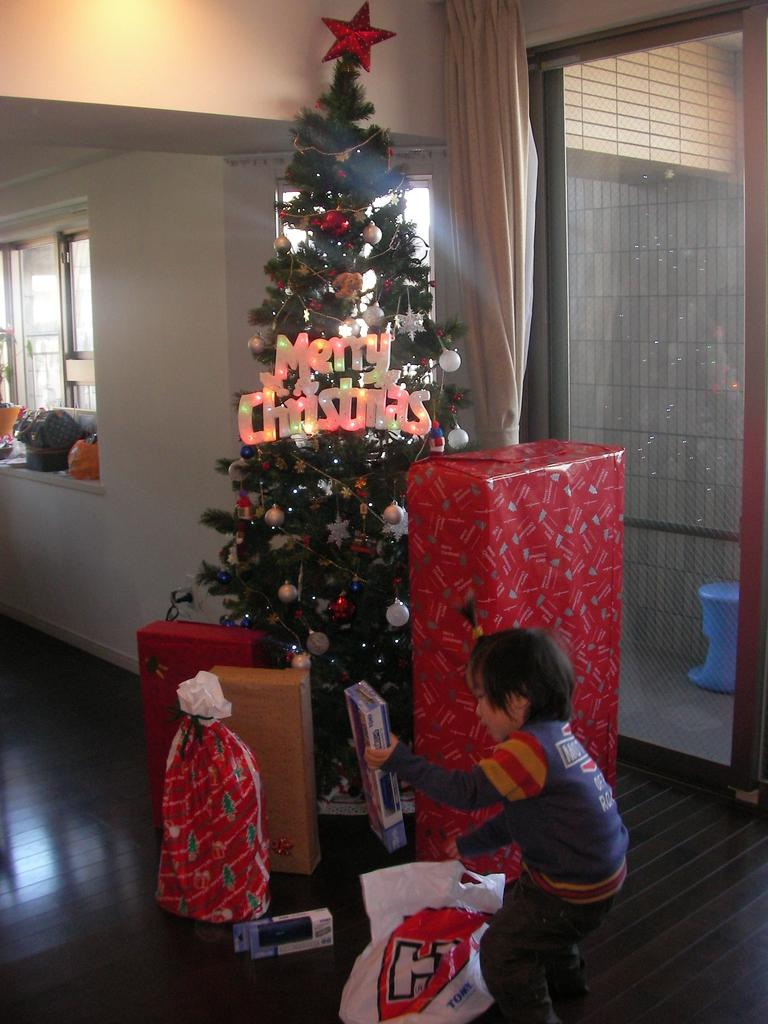<image>
Write a terse but informative summary of the picture. A boy in front of a Christmas tree with Merry Christmas illuminated 